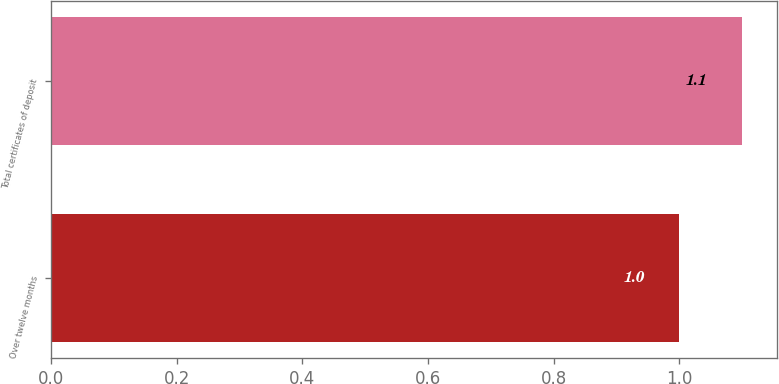Convert chart to OTSL. <chart><loc_0><loc_0><loc_500><loc_500><bar_chart><fcel>Over twelve months<fcel>Total certificates of deposit<nl><fcel>1<fcel>1.1<nl></chart> 